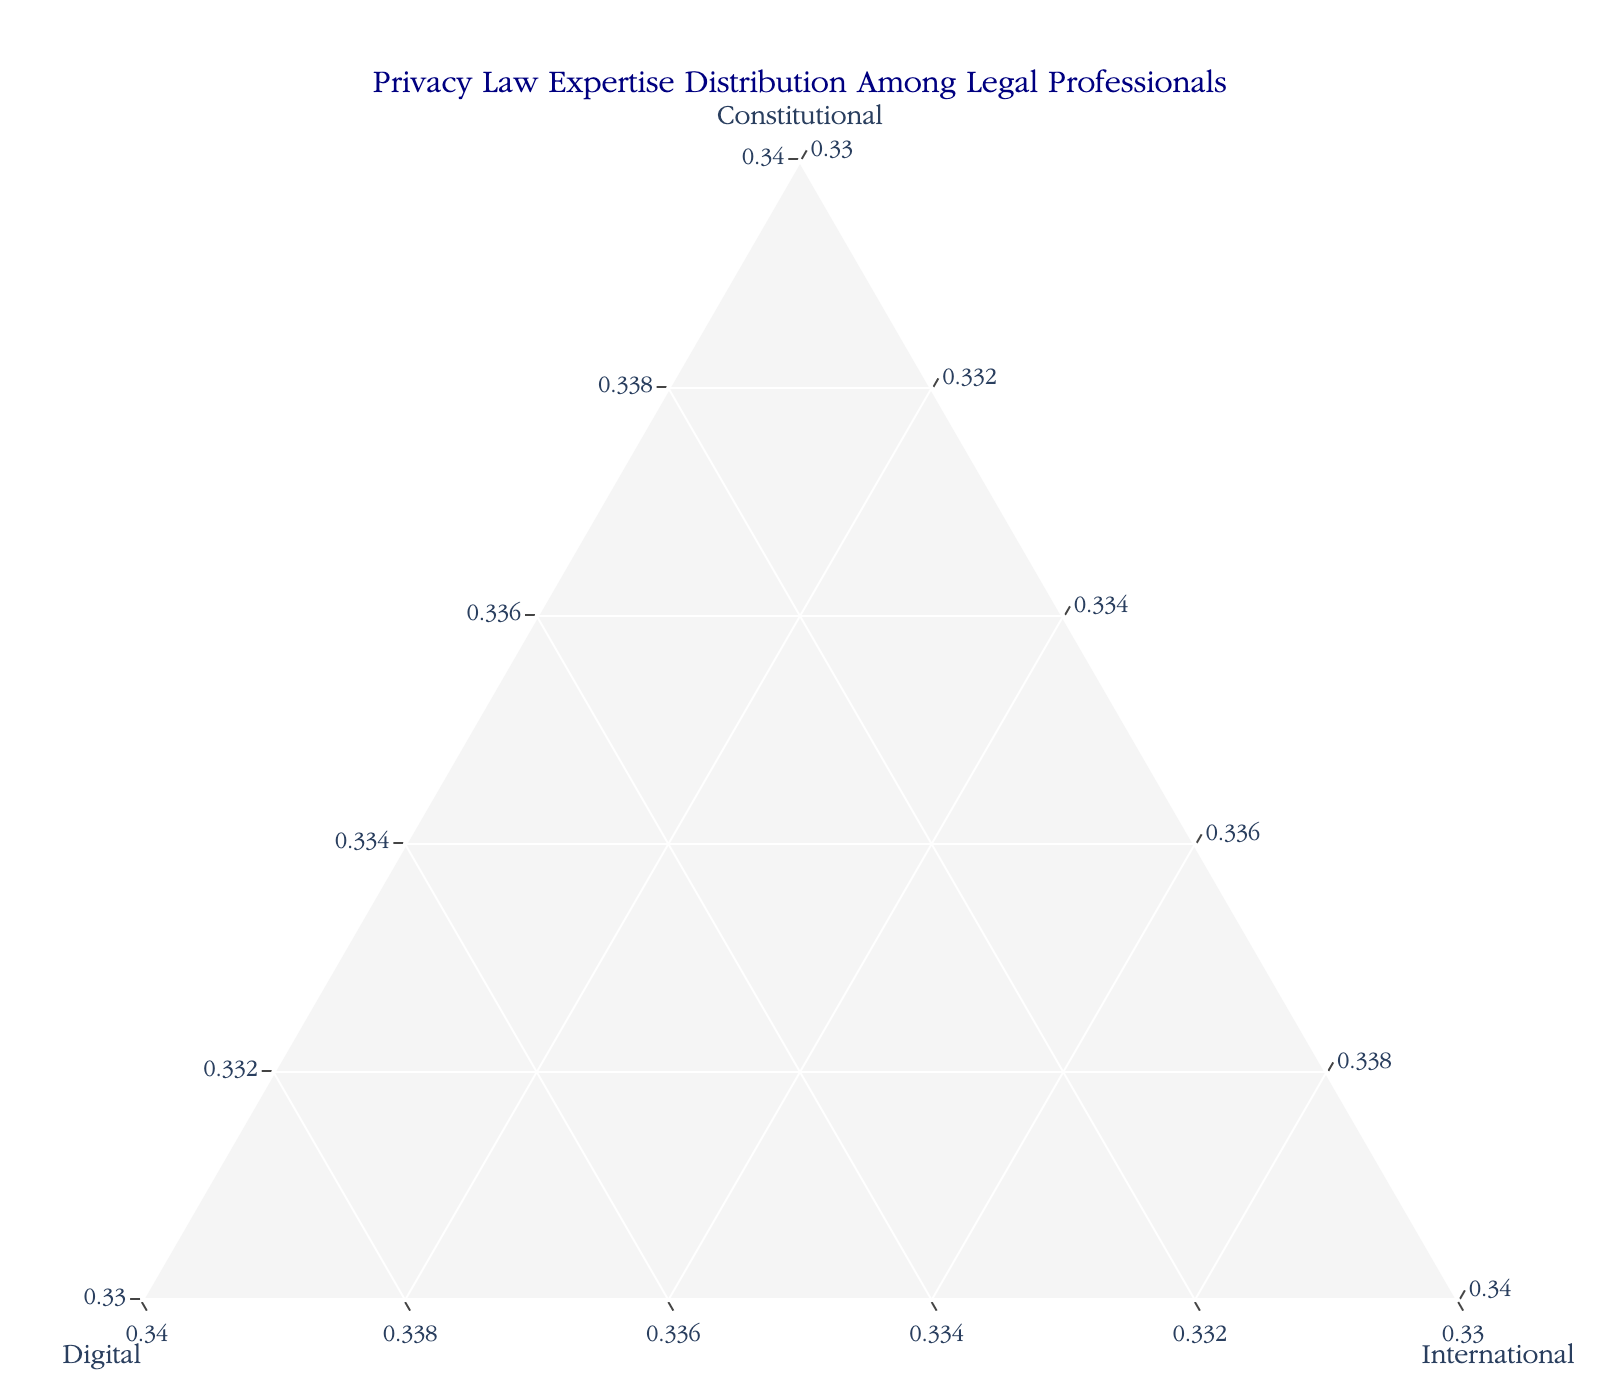How many legal professionals are represented in this figure? Count the number of data points representing legal professionals in the figure.
Answer: 14 Which legal professional shows the highest expertise in Digital privacy law? Identify the data point with the highest value on the Digital axis. Laurence Tribe has the highest Digital expertise with a proportion of 0.45.
Answer: Laurence Tribe What is the combined proportion of expertise in Constitutional and Digital privacy law for Alan Dershowitz? Sum the proportions for Constitutional (0.45) and Digital (0.25) for Alan Dershowitz. 0.45 + 0.25 = 0.70
Answer: 0.70 Who has the lowest expertise in International privacy law, and what is their proportion? Look for the data point with the smallest value on the International axis. Both Antonin Scalia and Clarence Thomas have the lowest expertise in International privacy law at 0.15.
Answer: Antonin Scalia and Clarence Thomas, 0.15 Which legal professionals have an equal proportion in Digital and International privacy law? Identify the data points where the values for Digital and International privacy law are the same. Elena Kagan and Ruth Bader Ginsburg both have 0.20 in Digital and International privacy law.
Answer: Elena Kagan and Ruth Bader Ginsburg What is the average proportion of Constitutional privacy law expertise among the listed legal professionals? Sum the values for Constitutional expertise and divide by the number of professionals. The sum is 0.60 + 0.70 + 0.50 + 0.55 + 0.45 + 0.50 + 0.65 + 0.55 + 0.40 + 0.45 + 0.50 + 0.40 + 0.35 + 0.45 = 6.55. Dividing by 14 gives the average: 6.55 / 14 ≈ 0.47
Answer: ≈ 0.47 Who has a higher expertise in Digital privacy law, Sonia Sotomayor or Samuel Alito? Compare the Digital privacy law proportions for both individuals. Sonia Sotomayor has 0.35, while Samuel Alito has 0.30.
Answer: Sonia Sotomayor What is the difference in expertise in International privacy law between Stephen Breyer and Merrick Garland? Subtract the International expertise values for the two legal professionals. Stephen Breyer's expertise is 0.30, and Merrick Garland's is 0.30. 0.30 - 0.30 = 0
Answer: 0 Do any legal professionals have equal expertise in all three areas of privacy law? Check if any data points have equal values for Constitutional, Digital, and International axes. None of the legal professionals have equal expertise in all three areas.
Answer: No How many legal professionals have a Constitutional expertise proportion greater than 0.50? Count the data points where the Constitutional expertise proportion is greater than 0.50. Ruth Bader Ginsburg, Antonin Scalia, John Roberts, Clarence Thomas, and Samuel Alito make up five professionals.
Answer: 5 